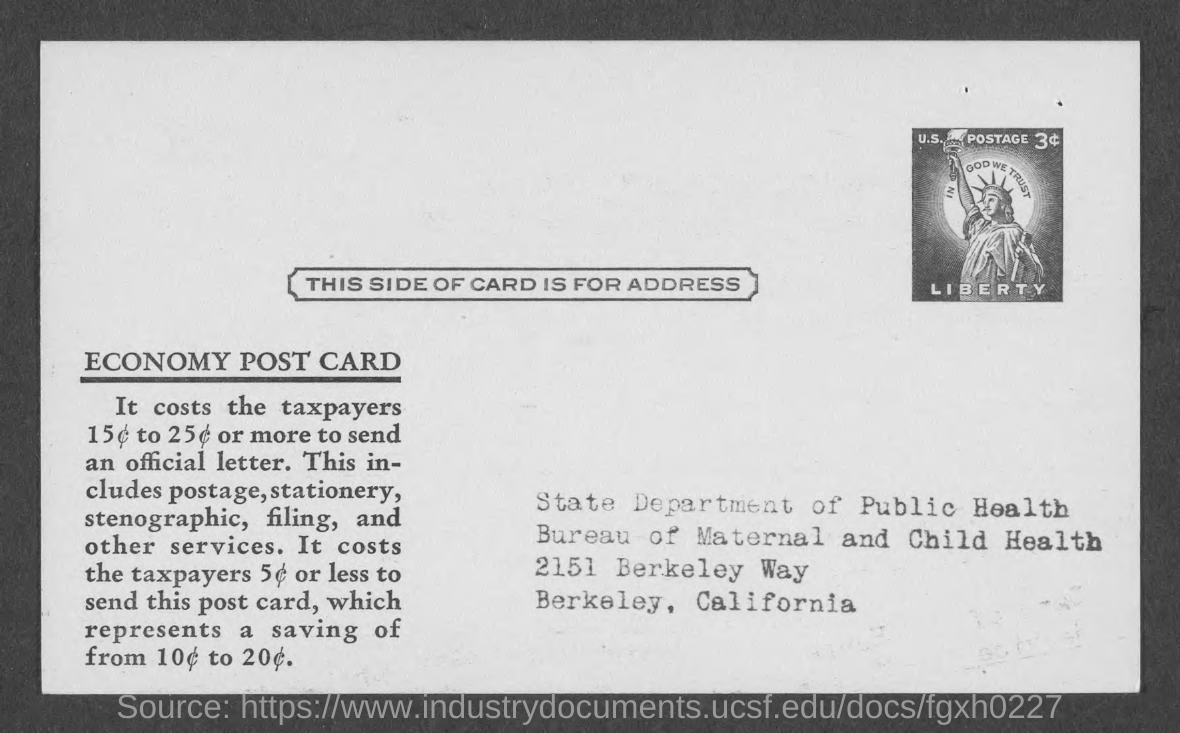Specify some key components in this picture. The address given mentions the State Department of Public Health. 